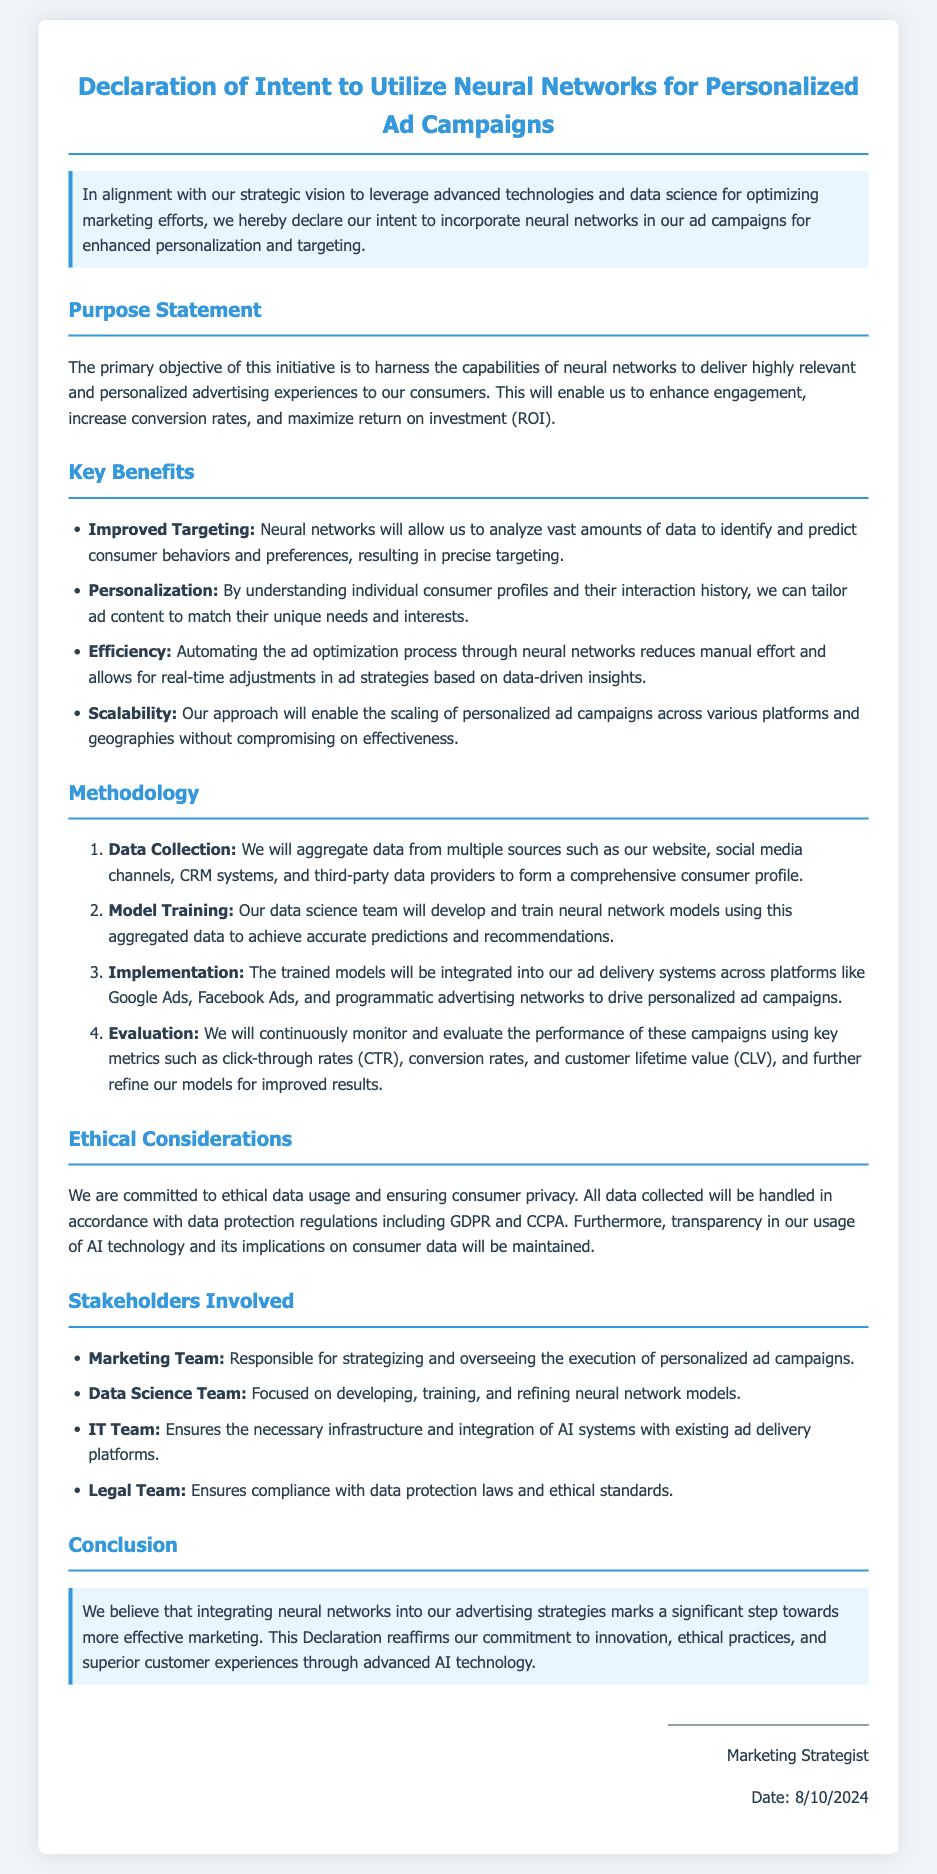What is the primary objective of the initiative? The primary objective is to harness the capabilities of neural networks for enhanced personalization and targeting in advertising.
Answer: Enhanced personalization and targeting What are the key benefits listed? The document lists benefits such as improved targeting, personalization, efficiency, and scalability.
Answer: Improved targeting, personalization, efficiency, scalability Who is responsible for overseeing the execution of personalized ad campaigns? This responsibility falls to the marketing team as stated in the document.
Answer: Marketing Team What regulations does the document mention for data usage? The declaration mentions GDPR and CCPA as the regulations for ethical data usage.
Answer: GDPR and CCPA How many steps are involved in the methodology? The methodology section outlines four distinct steps for utilizing neural networks.
Answer: Four What will be continuously monitored to evaluate campaign performance? The document states that click-through rates, conversion rates, and customer lifetime value will be monitored.
Answer: Click-through rates, conversion rates, customer lifetime value What does the declaration emphasize regarding consumer privacy? The declaration emphasizes a commitment to ethical data usage and ensuring consumer privacy.
Answer: Ethical data usage and ensuring consumer privacy What is the title of this document? The title clearly indicated in the document is "Declaration of Intent to Utilize Neural Networks for Personalized Ad Campaigns."
Answer: Declaration of Intent to Utilize Neural Networks for Personalized Ad Campaigns 